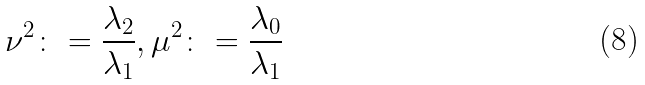Convert formula to latex. <formula><loc_0><loc_0><loc_500><loc_500>\nu ^ { 2 } \colon = \frac { \lambda _ { 2 } } { \lambda _ { 1 } } , \mu ^ { 2 } \colon = \frac { \lambda _ { 0 } } { \lambda _ { 1 } }</formula> 